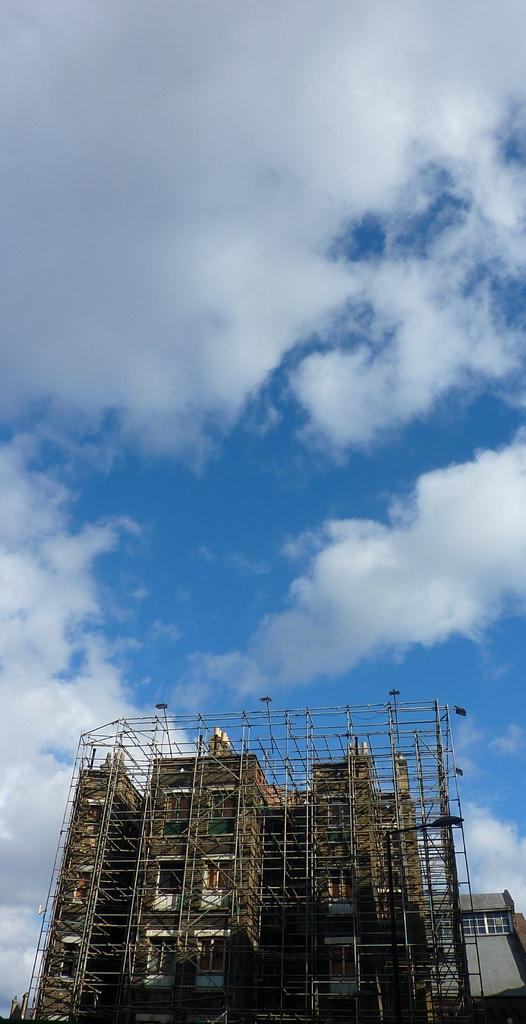What is the main subject of the image? The main subject of the image is an under construction building. Can you describe the surrounding area in the image? There is a house behind the under construction building. What can be seen in the sky in the image? Clouds are visible in the image. How many ladybugs can be seen on the rake in the image? There are no ladybugs or rakes present in the image. Is the scene taking place during the night in the image? The image does not provide any information about the time of day, but there is no indication of it being nighttime. 